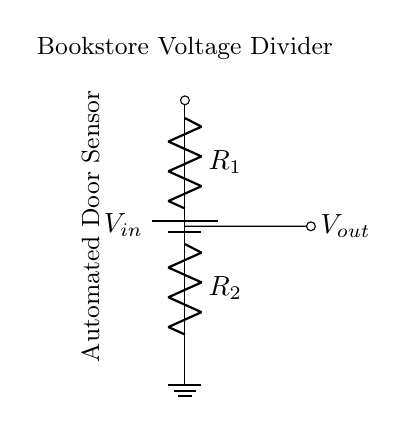What is the type of sensor in this circuit? The circuit includes an "Automated Door Sensor" indicated in the diagram.
Answer: Automated Door Sensor What is the input voltage to the voltage divider? The input voltage is labeled as \(V_{in}\) at the top of the circuit diagram.
Answer: \(V_{in}\) How many resistors are present in the voltage divider? The circuit has two resistors, \(R_1\) and \(R_2\), shown connected in series.
Answer: Two What is the voltage output measured across? The output voltage \(V_{out}\) is measured across the resistor \(R_2\) as indicated by the connection to the right of the second resistor.
Answer: \(R_2\) What is the role of the voltage divider in the bookstore's system? The voltage divider is used to reduce the input voltage to a lower level suitable for the sensor input.
Answer: To reduce voltage If \(R_1\) is 1kΩ and \(R_2\) is 2kΩ, what is the ratio of the resistances? The ratio of the resistances is calculated as \(R_1:R_2 = 1:2\), implying \(R_1\) is half of \(R_2\).
Answer: 1:2 How does changing \(R_1\) affect the output voltage \(V_{out}\)? Increasing \(R_1\) will increase the output voltage \(V_{out}\) because it affects the voltage drop across the resistors proportionally.
Answer: Increases \(V_{out}\) 